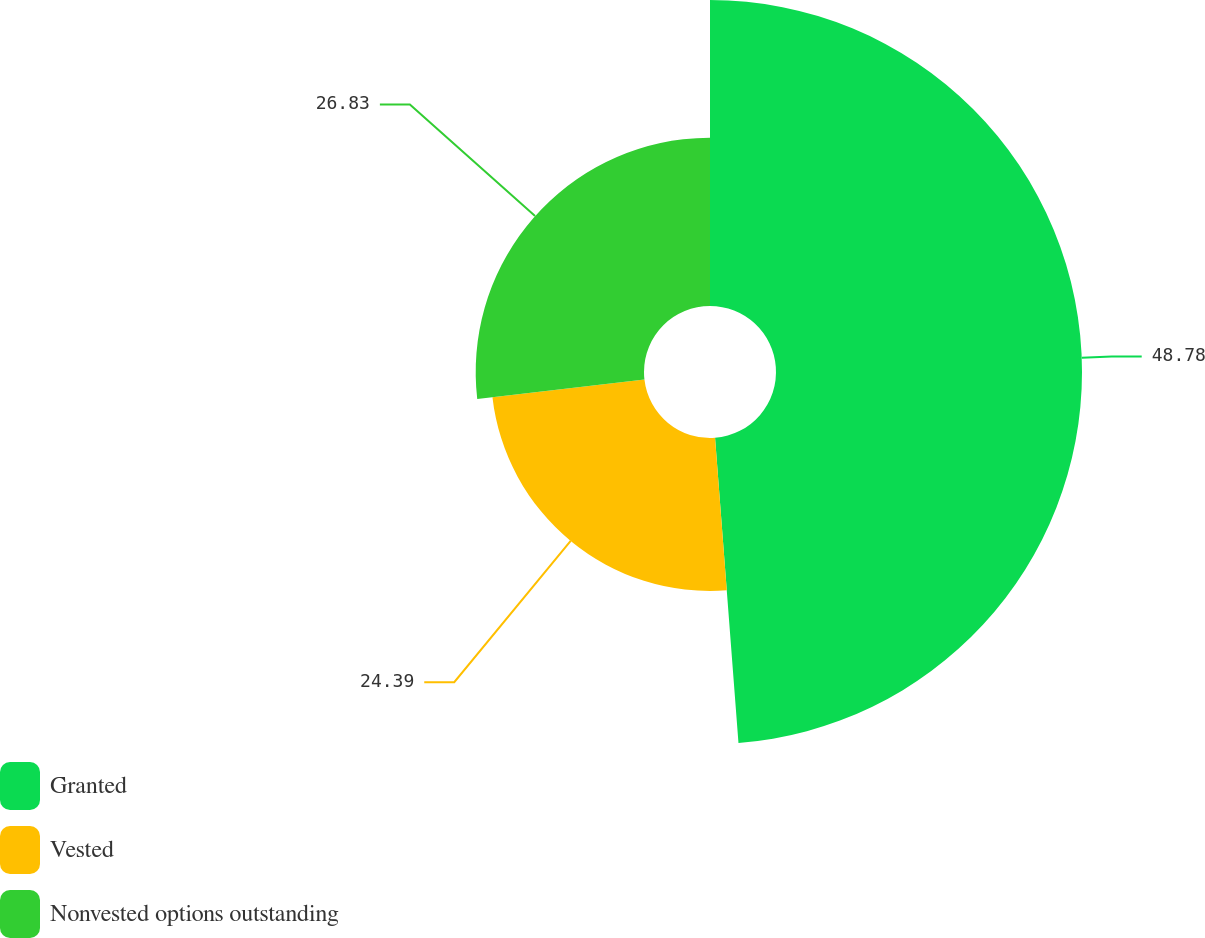Convert chart. <chart><loc_0><loc_0><loc_500><loc_500><pie_chart><fcel>Granted<fcel>Vested<fcel>Nonvested options outstanding<nl><fcel>48.78%<fcel>24.39%<fcel>26.83%<nl></chart> 